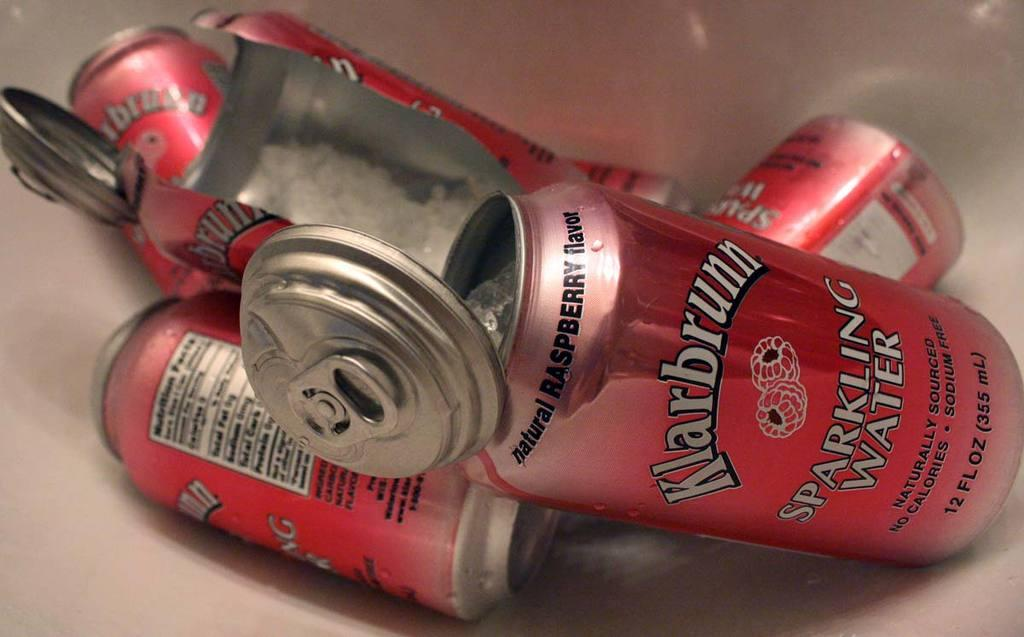<image>
Summarize the visual content of the image. a can that has the word sparkling on it 